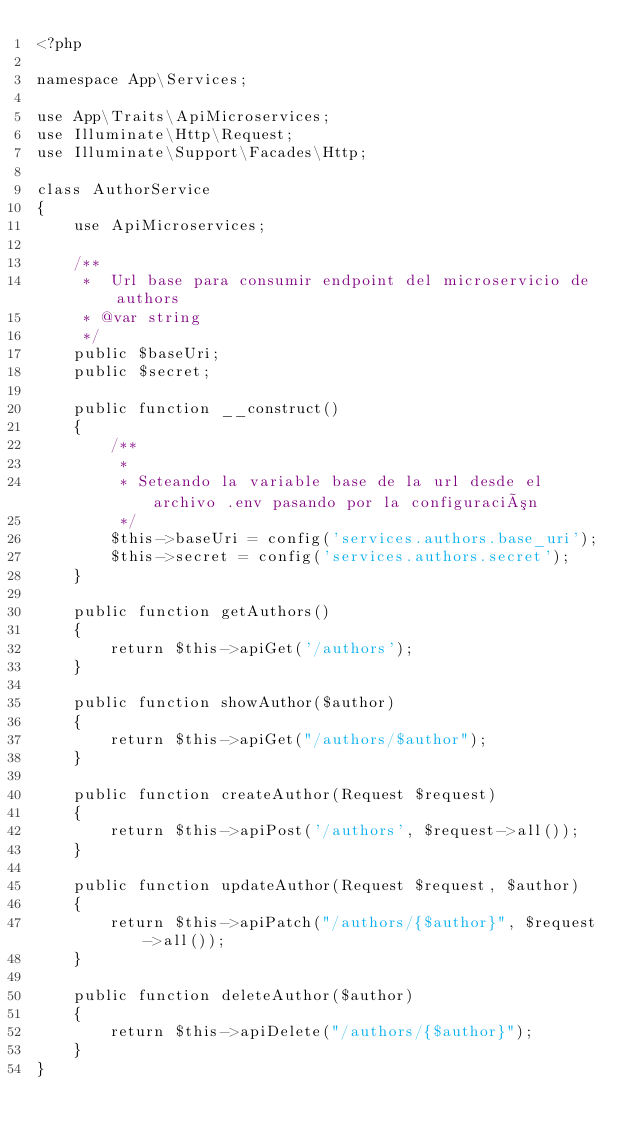Convert code to text. <code><loc_0><loc_0><loc_500><loc_500><_PHP_><?php

namespace App\Services;

use App\Traits\ApiMicroservices;
use Illuminate\Http\Request;
use Illuminate\Support\Facades\Http;

class AuthorService
{
    use ApiMicroservices;

    /**
     *  Url base para consumir endpoint del microservicio de authors
     * @var string
     */
    public $baseUri;
    public $secret;

    public function __construct()
    {
        /**
         *
         * Seteando la variable base de la url desde el archivo .env pasando por la configuración
         */
        $this->baseUri = config('services.authors.base_uri');
        $this->secret = config('services.authors.secret');
    }

    public function getAuthors()
    {
        return $this->apiGet('/authors');
    }

    public function showAuthor($author)
    {
        return $this->apiGet("/authors/$author");
    }

    public function createAuthor(Request $request)
    {
        return $this->apiPost('/authors', $request->all());
    }

    public function updateAuthor(Request $request, $author)
    {
        return $this->apiPatch("/authors/{$author}", $request->all());
    }

    public function deleteAuthor($author)
    {
        return $this->apiDelete("/authors/{$author}");
    }
}
</code> 